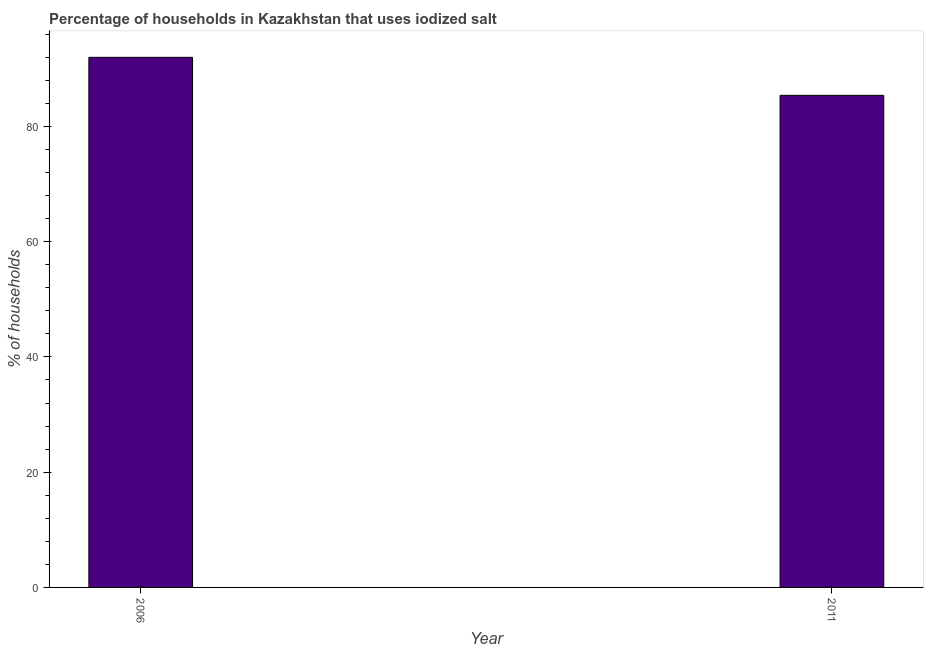What is the title of the graph?
Your answer should be very brief. Percentage of households in Kazakhstan that uses iodized salt. What is the label or title of the X-axis?
Offer a very short reply. Year. What is the label or title of the Y-axis?
Your answer should be compact. % of households. What is the percentage of households where iodized salt is consumed in 2006?
Make the answer very short. 92. Across all years, what is the maximum percentage of households where iodized salt is consumed?
Provide a succinct answer. 92. Across all years, what is the minimum percentage of households where iodized salt is consumed?
Your answer should be compact. 85.4. What is the sum of the percentage of households where iodized salt is consumed?
Your response must be concise. 177.4. What is the difference between the percentage of households where iodized salt is consumed in 2006 and 2011?
Provide a succinct answer. 6.6. What is the average percentage of households where iodized salt is consumed per year?
Provide a short and direct response. 88.7. What is the median percentage of households where iodized salt is consumed?
Your answer should be very brief. 88.7. What is the ratio of the percentage of households where iodized salt is consumed in 2006 to that in 2011?
Offer a very short reply. 1.08. In how many years, is the percentage of households where iodized salt is consumed greater than the average percentage of households where iodized salt is consumed taken over all years?
Provide a succinct answer. 1. Are all the bars in the graph horizontal?
Your answer should be compact. No. What is the difference between two consecutive major ticks on the Y-axis?
Give a very brief answer. 20. What is the % of households in 2006?
Give a very brief answer. 92. What is the % of households in 2011?
Your answer should be very brief. 85.4. What is the ratio of the % of households in 2006 to that in 2011?
Keep it short and to the point. 1.08. 